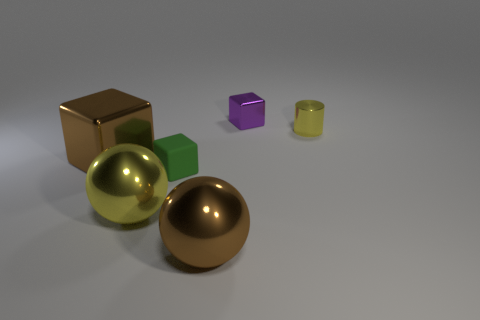Subtract all green cubes. How many cubes are left? 2 Add 1 tiny things. How many objects exist? 7 Subtract all yellow balls. How many balls are left? 1 Subtract 1 yellow cylinders. How many objects are left? 5 Subtract all cylinders. How many objects are left? 5 Subtract 2 spheres. How many spheres are left? 0 Subtract all cyan spheres. Subtract all green cylinders. How many spheres are left? 2 Subtract all red blocks. How many yellow spheres are left? 1 Subtract all small green cubes. Subtract all small yellow metallic cylinders. How many objects are left? 4 Add 5 green blocks. How many green blocks are left? 6 